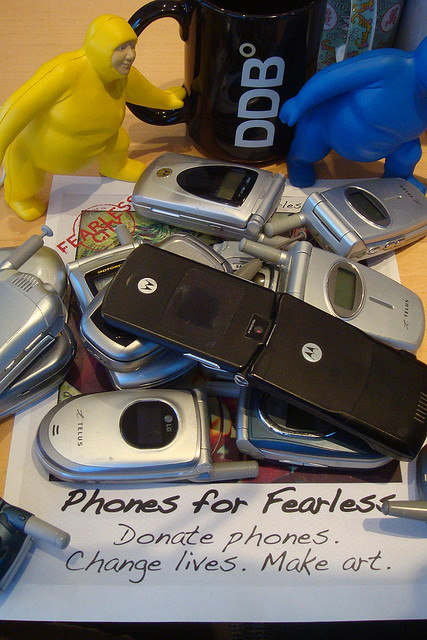Identify the text displayed in this image. DDB FEARLESS Phones for Fearless art Make phones lives change Donate TELUS 